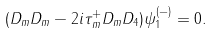<formula> <loc_0><loc_0><loc_500><loc_500>( D _ { m } D _ { m } - 2 i \tau _ { m } ^ { + } D _ { m } D _ { 4 } ) \psi _ { 1 } ^ { ( - ) } = 0 .</formula> 